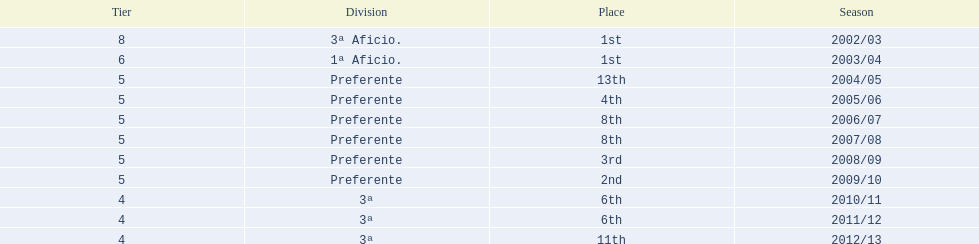Which seasons were played in tier four? 2010/11, 2011/12, 2012/13. Of these seasons, which resulted in 6th place? 2010/11, 2011/12. Which of the remaining happened last? 2011/12. 